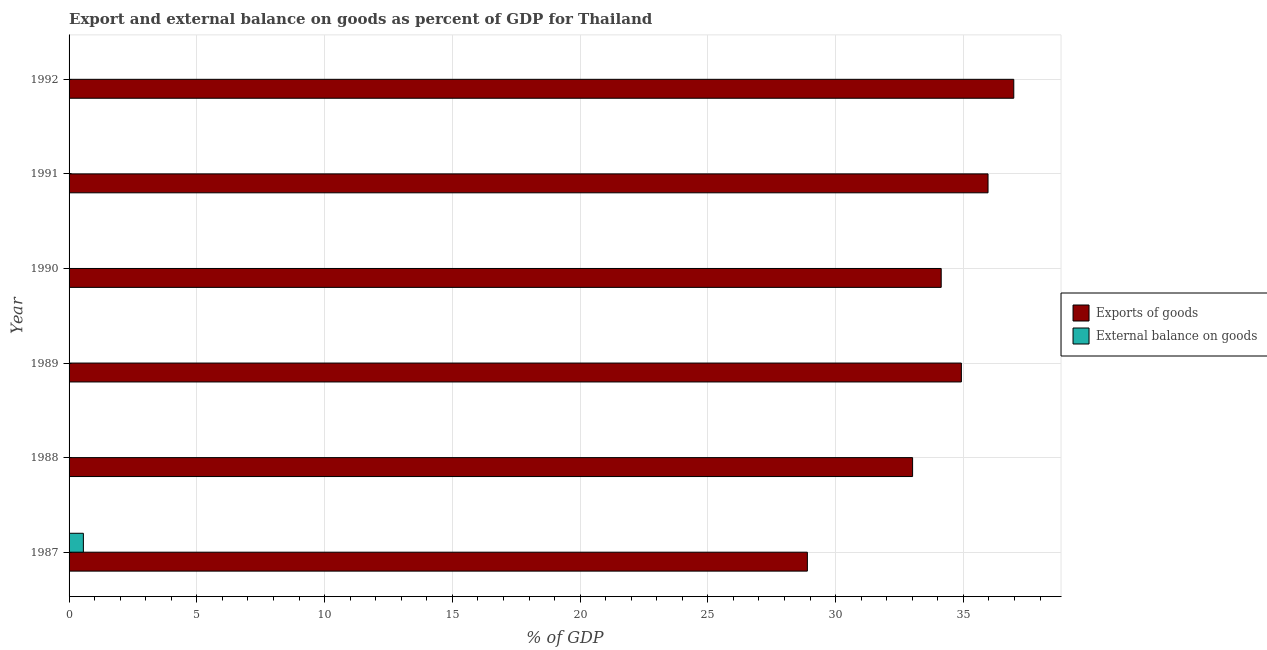How many different coloured bars are there?
Make the answer very short. 2. How many bars are there on the 6th tick from the top?
Give a very brief answer. 2. How many bars are there on the 6th tick from the bottom?
Ensure brevity in your answer.  1. In how many cases, is the number of bars for a given year not equal to the number of legend labels?
Your answer should be compact. 5. What is the external balance on goods as percentage of gdp in 1990?
Provide a short and direct response. 0. Across all years, what is the maximum export of goods as percentage of gdp?
Provide a succinct answer. 36.97. What is the total export of goods as percentage of gdp in the graph?
Offer a very short reply. 203.9. What is the difference between the export of goods as percentage of gdp in 1987 and that in 1988?
Provide a succinct answer. -4.12. What is the difference between the external balance on goods as percentage of gdp in 1988 and the export of goods as percentage of gdp in 1987?
Provide a succinct answer. -28.89. What is the average export of goods as percentage of gdp per year?
Provide a succinct answer. 33.98. In the year 1987, what is the difference between the export of goods as percentage of gdp and external balance on goods as percentage of gdp?
Ensure brevity in your answer.  28.33. What is the ratio of the export of goods as percentage of gdp in 1989 to that in 1991?
Provide a short and direct response. 0.97. Is the export of goods as percentage of gdp in 1989 less than that in 1992?
Offer a terse response. Yes. What is the difference between the highest and the lowest export of goods as percentage of gdp?
Give a very brief answer. 8.08. Are all the bars in the graph horizontal?
Give a very brief answer. Yes. How many years are there in the graph?
Your answer should be very brief. 6. What is the difference between two consecutive major ticks on the X-axis?
Your response must be concise. 5. Does the graph contain any zero values?
Make the answer very short. Yes. Does the graph contain grids?
Give a very brief answer. Yes. Where does the legend appear in the graph?
Keep it short and to the point. Center right. How are the legend labels stacked?
Offer a terse response. Vertical. What is the title of the graph?
Ensure brevity in your answer.  Export and external balance on goods as percent of GDP for Thailand. What is the label or title of the X-axis?
Your response must be concise. % of GDP. What is the label or title of the Y-axis?
Your answer should be very brief. Year. What is the % of GDP of Exports of goods in 1987?
Ensure brevity in your answer.  28.89. What is the % of GDP of External balance on goods in 1987?
Your answer should be very brief. 0.56. What is the % of GDP of Exports of goods in 1988?
Your answer should be very brief. 33.01. What is the % of GDP in External balance on goods in 1988?
Give a very brief answer. 0. What is the % of GDP of Exports of goods in 1989?
Offer a very short reply. 34.92. What is the % of GDP in External balance on goods in 1989?
Your answer should be very brief. 0. What is the % of GDP of Exports of goods in 1990?
Offer a very short reply. 34.13. What is the % of GDP of External balance on goods in 1990?
Your answer should be compact. 0. What is the % of GDP of Exports of goods in 1991?
Your response must be concise. 35.96. What is the % of GDP in External balance on goods in 1991?
Keep it short and to the point. 0. What is the % of GDP in Exports of goods in 1992?
Provide a short and direct response. 36.97. Across all years, what is the maximum % of GDP in Exports of goods?
Offer a very short reply. 36.97. Across all years, what is the maximum % of GDP of External balance on goods?
Provide a succinct answer. 0.56. Across all years, what is the minimum % of GDP of Exports of goods?
Your answer should be compact. 28.89. Across all years, what is the minimum % of GDP of External balance on goods?
Your response must be concise. 0. What is the total % of GDP in Exports of goods in the graph?
Your answer should be very brief. 203.9. What is the total % of GDP of External balance on goods in the graph?
Keep it short and to the point. 0.56. What is the difference between the % of GDP in Exports of goods in 1987 and that in 1988?
Give a very brief answer. -4.12. What is the difference between the % of GDP of Exports of goods in 1987 and that in 1989?
Your answer should be compact. -6.03. What is the difference between the % of GDP in Exports of goods in 1987 and that in 1990?
Your answer should be compact. -5.24. What is the difference between the % of GDP in Exports of goods in 1987 and that in 1991?
Your answer should be very brief. -7.07. What is the difference between the % of GDP in Exports of goods in 1987 and that in 1992?
Your answer should be very brief. -8.08. What is the difference between the % of GDP of Exports of goods in 1988 and that in 1989?
Provide a succinct answer. -1.91. What is the difference between the % of GDP of Exports of goods in 1988 and that in 1990?
Offer a very short reply. -1.12. What is the difference between the % of GDP of Exports of goods in 1988 and that in 1991?
Provide a succinct answer. -2.95. What is the difference between the % of GDP of Exports of goods in 1988 and that in 1992?
Offer a very short reply. -3.96. What is the difference between the % of GDP of Exports of goods in 1989 and that in 1990?
Your answer should be compact. 0.79. What is the difference between the % of GDP of Exports of goods in 1989 and that in 1991?
Your answer should be very brief. -1.04. What is the difference between the % of GDP of Exports of goods in 1989 and that in 1992?
Your answer should be very brief. -2.05. What is the difference between the % of GDP in Exports of goods in 1990 and that in 1991?
Your response must be concise. -1.83. What is the difference between the % of GDP in Exports of goods in 1990 and that in 1992?
Offer a terse response. -2.84. What is the difference between the % of GDP in Exports of goods in 1991 and that in 1992?
Your answer should be very brief. -1.01. What is the average % of GDP of Exports of goods per year?
Provide a short and direct response. 33.98. What is the average % of GDP of External balance on goods per year?
Provide a succinct answer. 0.09. In the year 1987, what is the difference between the % of GDP in Exports of goods and % of GDP in External balance on goods?
Provide a short and direct response. 28.33. What is the ratio of the % of GDP of Exports of goods in 1987 to that in 1988?
Offer a very short reply. 0.88. What is the ratio of the % of GDP of Exports of goods in 1987 to that in 1989?
Offer a terse response. 0.83. What is the ratio of the % of GDP of Exports of goods in 1987 to that in 1990?
Provide a succinct answer. 0.85. What is the ratio of the % of GDP of Exports of goods in 1987 to that in 1991?
Make the answer very short. 0.8. What is the ratio of the % of GDP of Exports of goods in 1987 to that in 1992?
Provide a succinct answer. 0.78. What is the ratio of the % of GDP in Exports of goods in 1988 to that in 1989?
Keep it short and to the point. 0.95. What is the ratio of the % of GDP in Exports of goods in 1988 to that in 1990?
Your answer should be very brief. 0.97. What is the ratio of the % of GDP in Exports of goods in 1988 to that in 1991?
Provide a succinct answer. 0.92. What is the ratio of the % of GDP in Exports of goods in 1988 to that in 1992?
Give a very brief answer. 0.89. What is the ratio of the % of GDP in Exports of goods in 1989 to that in 1990?
Make the answer very short. 1.02. What is the ratio of the % of GDP of Exports of goods in 1989 to that in 1991?
Keep it short and to the point. 0.97. What is the ratio of the % of GDP in Exports of goods in 1989 to that in 1992?
Your answer should be compact. 0.94. What is the ratio of the % of GDP in Exports of goods in 1990 to that in 1991?
Ensure brevity in your answer.  0.95. What is the ratio of the % of GDP in Exports of goods in 1990 to that in 1992?
Your response must be concise. 0.92. What is the ratio of the % of GDP in Exports of goods in 1991 to that in 1992?
Offer a very short reply. 0.97. What is the difference between the highest and the second highest % of GDP in Exports of goods?
Offer a terse response. 1.01. What is the difference between the highest and the lowest % of GDP in Exports of goods?
Provide a succinct answer. 8.08. What is the difference between the highest and the lowest % of GDP of External balance on goods?
Your answer should be compact. 0.56. 